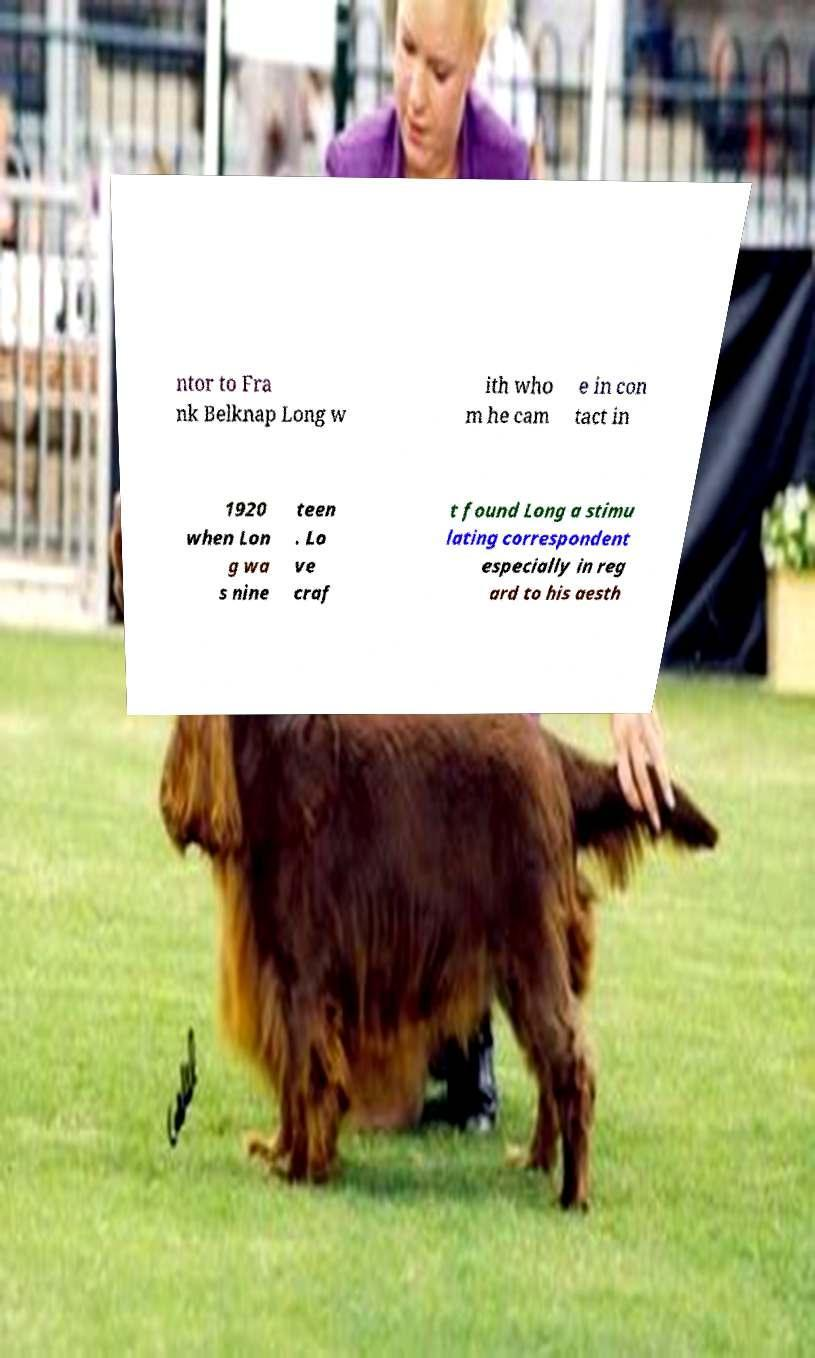Please read and relay the text visible in this image. What does it say? ntor to Fra nk Belknap Long w ith who m he cam e in con tact in 1920 when Lon g wa s nine teen . Lo ve craf t found Long a stimu lating correspondent especially in reg ard to his aesth 